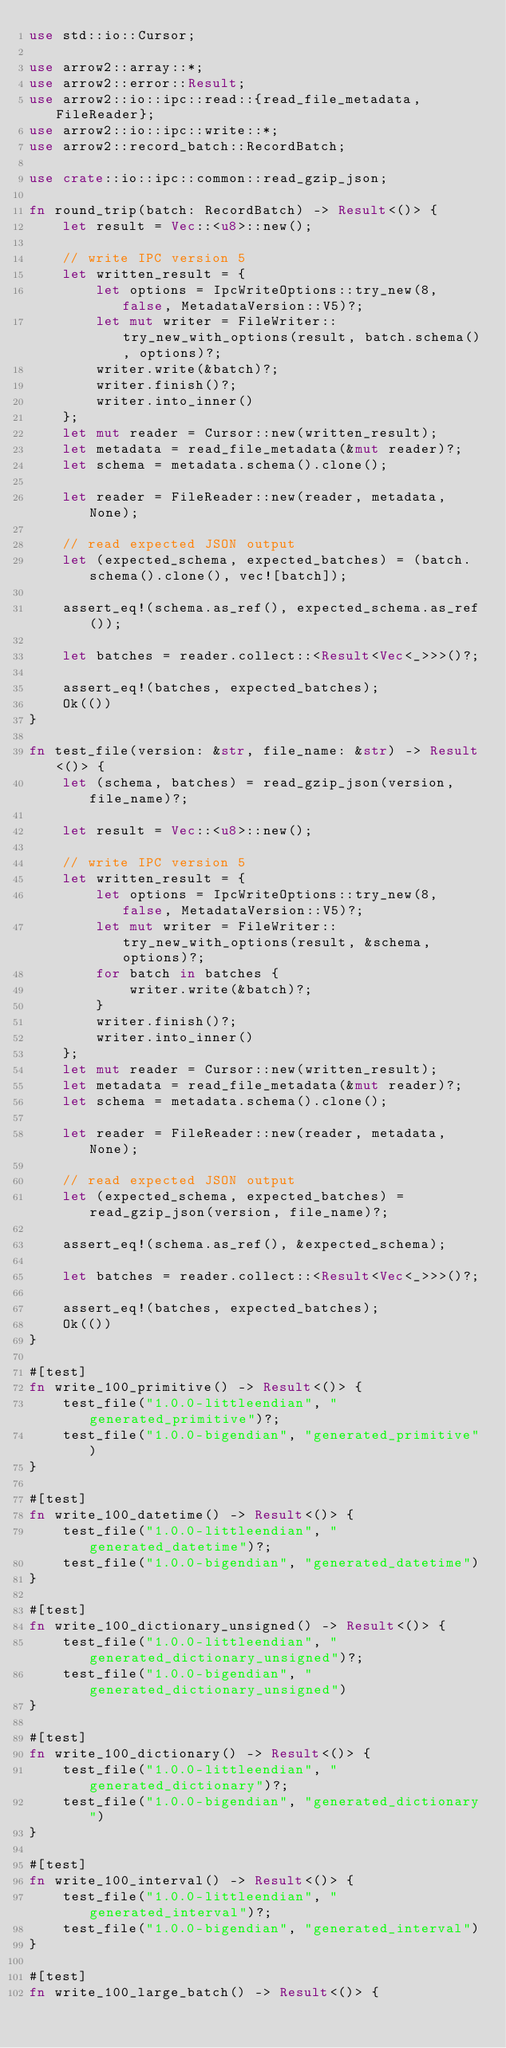Convert code to text. <code><loc_0><loc_0><loc_500><loc_500><_Rust_>use std::io::Cursor;

use arrow2::array::*;
use arrow2::error::Result;
use arrow2::io::ipc::read::{read_file_metadata, FileReader};
use arrow2::io::ipc::write::*;
use arrow2::record_batch::RecordBatch;

use crate::io::ipc::common::read_gzip_json;

fn round_trip(batch: RecordBatch) -> Result<()> {
    let result = Vec::<u8>::new();

    // write IPC version 5
    let written_result = {
        let options = IpcWriteOptions::try_new(8, false, MetadataVersion::V5)?;
        let mut writer = FileWriter::try_new_with_options(result, batch.schema(), options)?;
        writer.write(&batch)?;
        writer.finish()?;
        writer.into_inner()
    };
    let mut reader = Cursor::new(written_result);
    let metadata = read_file_metadata(&mut reader)?;
    let schema = metadata.schema().clone();

    let reader = FileReader::new(reader, metadata, None);

    // read expected JSON output
    let (expected_schema, expected_batches) = (batch.schema().clone(), vec![batch]);

    assert_eq!(schema.as_ref(), expected_schema.as_ref());

    let batches = reader.collect::<Result<Vec<_>>>()?;

    assert_eq!(batches, expected_batches);
    Ok(())
}

fn test_file(version: &str, file_name: &str) -> Result<()> {
    let (schema, batches) = read_gzip_json(version, file_name)?;

    let result = Vec::<u8>::new();

    // write IPC version 5
    let written_result = {
        let options = IpcWriteOptions::try_new(8, false, MetadataVersion::V5)?;
        let mut writer = FileWriter::try_new_with_options(result, &schema, options)?;
        for batch in batches {
            writer.write(&batch)?;
        }
        writer.finish()?;
        writer.into_inner()
    };
    let mut reader = Cursor::new(written_result);
    let metadata = read_file_metadata(&mut reader)?;
    let schema = metadata.schema().clone();

    let reader = FileReader::new(reader, metadata, None);

    // read expected JSON output
    let (expected_schema, expected_batches) = read_gzip_json(version, file_name)?;

    assert_eq!(schema.as_ref(), &expected_schema);

    let batches = reader.collect::<Result<Vec<_>>>()?;

    assert_eq!(batches, expected_batches);
    Ok(())
}

#[test]
fn write_100_primitive() -> Result<()> {
    test_file("1.0.0-littleendian", "generated_primitive")?;
    test_file("1.0.0-bigendian", "generated_primitive")
}

#[test]
fn write_100_datetime() -> Result<()> {
    test_file("1.0.0-littleendian", "generated_datetime")?;
    test_file("1.0.0-bigendian", "generated_datetime")
}

#[test]
fn write_100_dictionary_unsigned() -> Result<()> {
    test_file("1.0.0-littleendian", "generated_dictionary_unsigned")?;
    test_file("1.0.0-bigendian", "generated_dictionary_unsigned")
}

#[test]
fn write_100_dictionary() -> Result<()> {
    test_file("1.0.0-littleendian", "generated_dictionary")?;
    test_file("1.0.0-bigendian", "generated_dictionary")
}

#[test]
fn write_100_interval() -> Result<()> {
    test_file("1.0.0-littleendian", "generated_interval")?;
    test_file("1.0.0-bigendian", "generated_interval")
}

#[test]
fn write_100_large_batch() -> Result<()> {</code> 